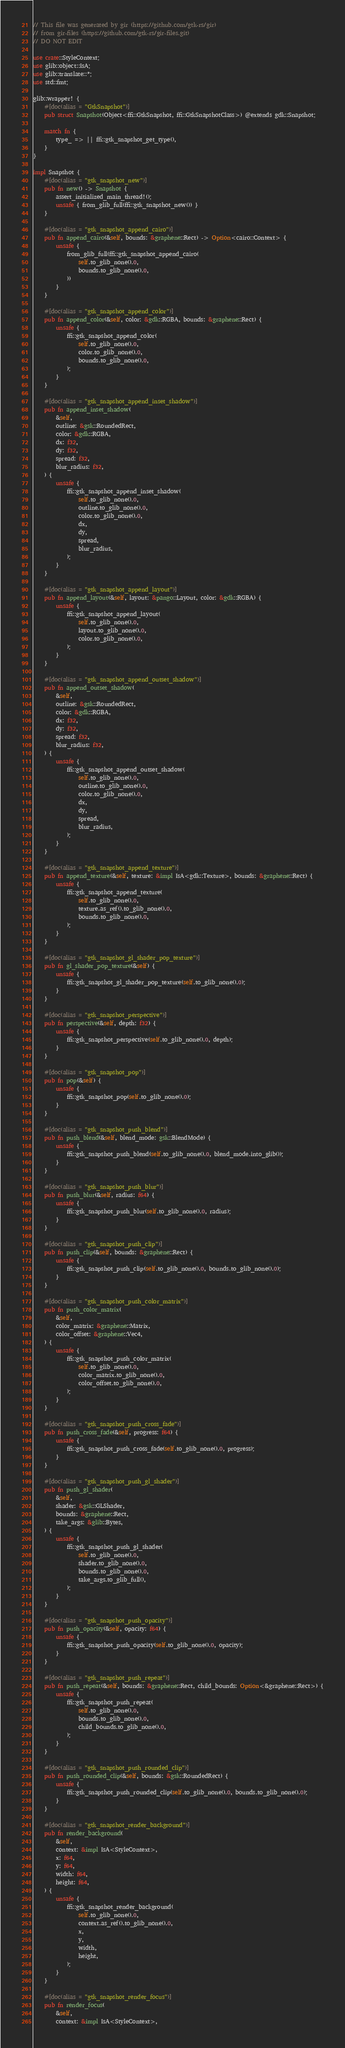<code> <loc_0><loc_0><loc_500><loc_500><_Rust_>// This file was generated by gir (https://github.com/gtk-rs/gir)
// from gir-files (https://github.com/gtk-rs/gir-files.git)
// DO NOT EDIT

use crate::StyleContext;
use glib::object::IsA;
use glib::translate::*;
use std::fmt;

glib::wrapper! {
    #[doc(alias = "GtkSnapshot")]
    pub struct Snapshot(Object<ffi::GtkSnapshot, ffi::GtkSnapshotClass>) @extends gdk::Snapshot;

    match fn {
        type_ => || ffi::gtk_snapshot_get_type(),
    }
}

impl Snapshot {
    #[doc(alias = "gtk_snapshot_new")]
    pub fn new() -> Snapshot {
        assert_initialized_main_thread!();
        unsafe { from_glib_full(ffi::gtk_snapshot_new()) }
    }

    #[doc(alias = "gtk_snapshot_append_cairo")]
    pub fn append_cairo(&self, bounds: &graphene::Rect) -> Option<cairo::Context> {
        unsafe {
            from_glib_full(ffi::gtk_snapshot_append_cairo(
                self.to_glib_none().0,
                bounds.to_glib_none().0,
            ))
        }
    }

    #[doc(alias = "gtk_snapshot_append_color")]
    pub fn append_color(&self, color: &gdk::RGBA, bounds: &graphene::Rect) {
        unsafe {
            ffi::gtk_snapshot_append_color(
                self.to_glib_none().0,
                color.to_glib_none().0,
                bounds.to_glib_none().0,
            );
        }
    }

    #[doc(alias = "gtk_snapshot_append_inset_shadow")]
    pub fn append_inset_shadow(
        &self,
        outline: &gsk::RoundedRect,
        color: &gdk::RGBA,
        dx: f32,
        dy: f32,
        spread: f32,
        blur_radius: f32,
    ) {
        unsafe {
            ffi::gtk_snapshot_append_inset_shadow(
                self.to_glib_none().0,
                outline.to_glib_none().0,
                color.to_glib_none().0,
                dx,
                dy,
                spread,
                blur_radius,
            );
        }
    }

    #[doc(alias = "gtk_snapshot_append_layout")]
    pub fn append_layout(&self, layout: &pango::Layout, color: &gdk::RGBA) {
        unsafe {
            ffi::gtk_snapshot_append_layout(
                self.to_glib_none().0,
                layout.to_glib_none().0,
                color.to_glib_none().0,
            );
        }
    }

    #[doc(alias = "gtk_snapshot_append_outset_shadow")]
    pub fn append_outset_shadow(
        &self,
        outline: &gsk::RoundedRect,
        color: &gdk::RGBA,
        dx: f32,
        dy: f32,
        spread: f32,
        blur_radius: f32,
    ) {
        unsafe {
            ffi::gtk_snapshot_append_outset_shadow(
                self.to_glib_none().0,
                outline.to_glib_none().0,
                color.to_glib_none().0,
                dx,
                dy,
                spread,
                blur_radius,
            );
        }
    }

    #[doc(alias = "gtk_snapshot_append_texture")]
    pub fn append_texture(&self, texture: &impl IsA<gdk::Texture>, bounds: &graphene::Rect) {
        unsafe {
            ffi::gtk_snapshot_append_texture(
                self.to_glib_none().0,
                texture.as_ref().to_glib_none().0,
                bounds.to_glib_none().0,
            );
        }
    }

    #[doc(alias = "gtk_snapshot_gl_shader_pop_texture")]
    pub fn gl_shader_pop_texture(&self) {
        unsafe {
            ffi::gtk_snapshot_gl_shader_pop_texture(self.to_glib_none().0);
        }
    }

    #[doc(alias = "gtk_snapshot_perspective")]
    pub fn perspective(&self, depth: f32) {
        unsafe {
            ffi::gtk_snapshot_perspective(self.to_glib_none().0, depth);
        }
    }

    #[doc(alias = "gtk_snapshot_pop")]
    pub fn pop(&self) {
        unsafe {
            ffi::gtk_snapshot_pop(self.to_glib_none().0);
        }
    }

    #[doc(alias = "gtk_snapshot_push_blend")]
    pub fn push_blend(&self, blend_mode: gsk::BlendMode) {
        unsafe {
            ffi::gtk_snapshot_push_blend(self.to_glib_none().0, blend_mode.into_glib());
        }
    }

    #[doc(alias = "gtk_snapshot_push_blur")]
    pub fn push_blur(&self, radius: f64) {
        unsafe {
            ffi::gtk_snapshot_push_blur(self.to_glib_none().0, radius);
        }
    }

    #[doc(alias = "gtk_snapshot_push_clip")]
    pub fn push_clip(&self, bounds: &graphene::Rect) {
        unsafe {
            ffi::gtk_snapshot_push_clip(self.to_glib_none().0, bounds.to_glib_none().0);
        }
    }

    #[doc(alias = "gtk_snapshot_push_color_matrix")]
    pub fn push_color_matrix(
        &self,
        color_matrix: &graphene::Matrix,
        color_offset: &graphene::Vec4,
    ) {
        unsafe {
            ffi::gtk_snapshot_push_color_matrix(
                self.to_glib_none().0,
                color_matrix.to_glib_none().0,
                color_offset.to_glib_none().0,
            );
        }
    }

    #[doc(alias = "gtk_snapshot_push_cross_fade")]
    pub fn push_cross_fade(&self, progress: f64) {
        unsafe {
            ffi::gtk_snapshot_push_cross_fade(self.to_glib_none().0, progress);
        }
    }

    #[doc(alias = "gtk_snapshot_push_gl_shader")]
    pub fn push_gl_shader(
        &self,
        shader: &gsk::GLShader,
        bounds: &graphene::Rect,
        take_args: &glib::Bytes,
    ) {
        unsafe {
            ffi::gtk_snapshot_push_gl_shader(
                self.to_glib_none().0,
                shader.to_glib_none().0,
                bounds.to_glib_none().0,
                take_args.to_glib_full(),
            );
        }
    }

    #[doc(alias = "gtk_snapshot_push_opacity")]
    pub fn push_opacity(&self, opacity: f64) {
        unsafe {
            ffi::gtk_snapshot_push_opacity(self.to_glib_none().0, opacity);
        }
    }

    #[doc(alias = "gtk_snapshot_push_repeat")]
    pub fn push_repeat(&self, bounds: &graphene::Rect, child_bounds: Option<&graphene::Rect>) {
        unsafe {
            ffi::gtk_snapshot_push_repeat(
                self.to_glib_none().0,
                bounds.to_glib_none().0,
                child_bounds.to_glib_none().0,
            );
        }
    }

    #[doc(alias = "gtk_snapshot_push_rounded_clip")]
    pub fn push_rounded_clip(&self, bounds: &gsk::RoundedRect) {
        unsafe {
            ffi::gtk_snapshot_push_rounded_clip(self.to_glib_none().0, bounds.to_glib_none().0);
        }
    }

    #[doc(alias = "gtk_snapshot_render_background")]
    pub fn render_background(
        &self,
        context: &impl IsA<StyleContext>,
        x: f64,
        y: f64,
        width: f64,
        height: f64,
    ) {
        unsafe {
            ffi::gtk_snapshot_render_background(
                self.to_glib_none().0,
                context.as_ref().to_glib_none().0,
                x,
                y,
                width,
                height,
            );
        }
    }

    #[doc(alias = "gtk_snapshot_render_focus")]
    pub fn render_focus(
        &self,
        context: &impl IsA<StyleContext>,</code> 